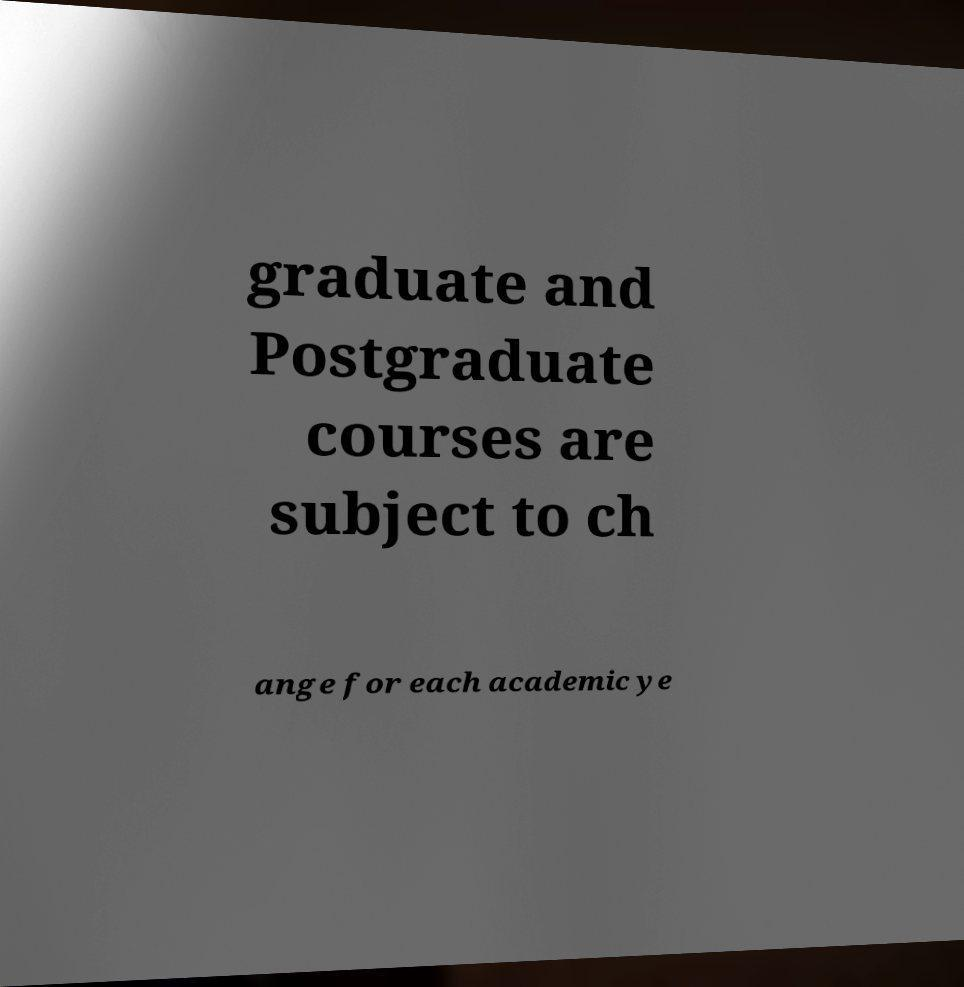What messages or text are displayed in this image? I need them in a readable, typed format. graduate and Postgraduate courses are subject to ch ange for each academic ye 